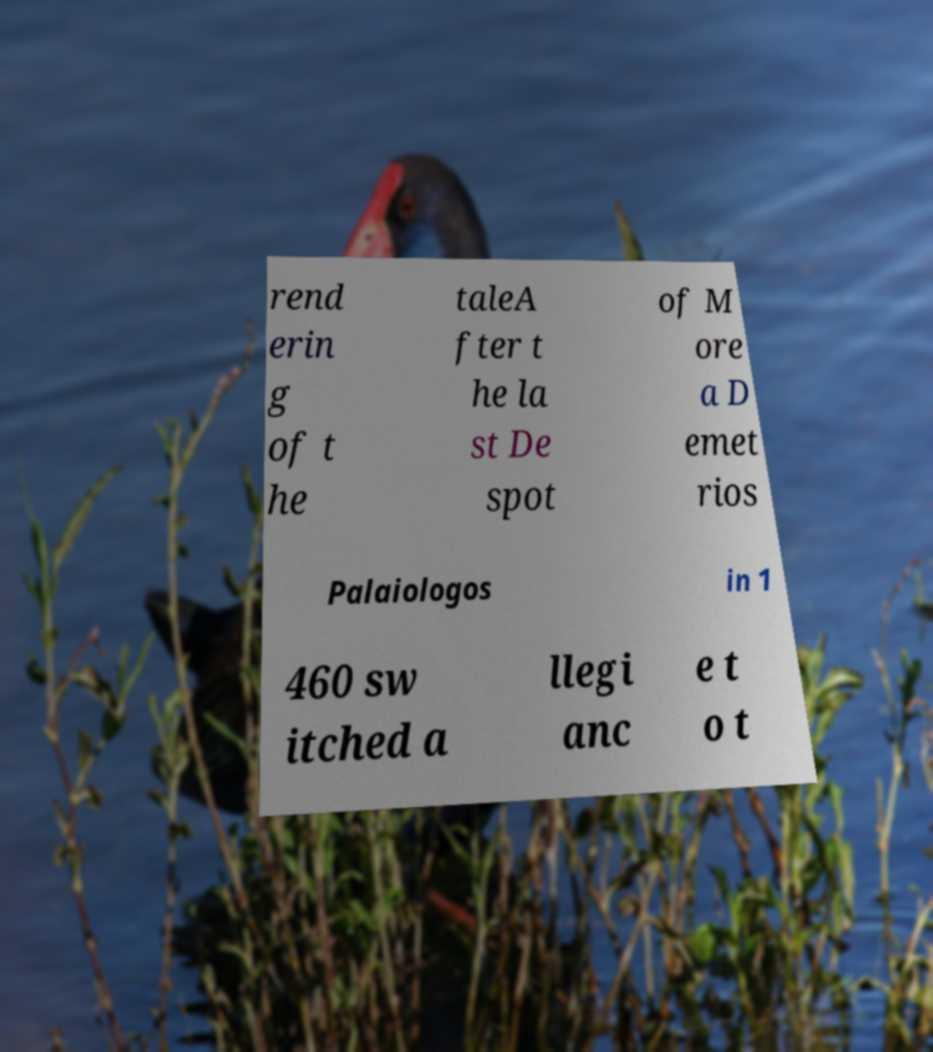I need the written content from this picture converted into text. Can you do that? rend erin g of t he taleA fter t he la st De spot of M ore a D emet rios Palaiologos in 1 460 sw itched a llegi anc e t o t 